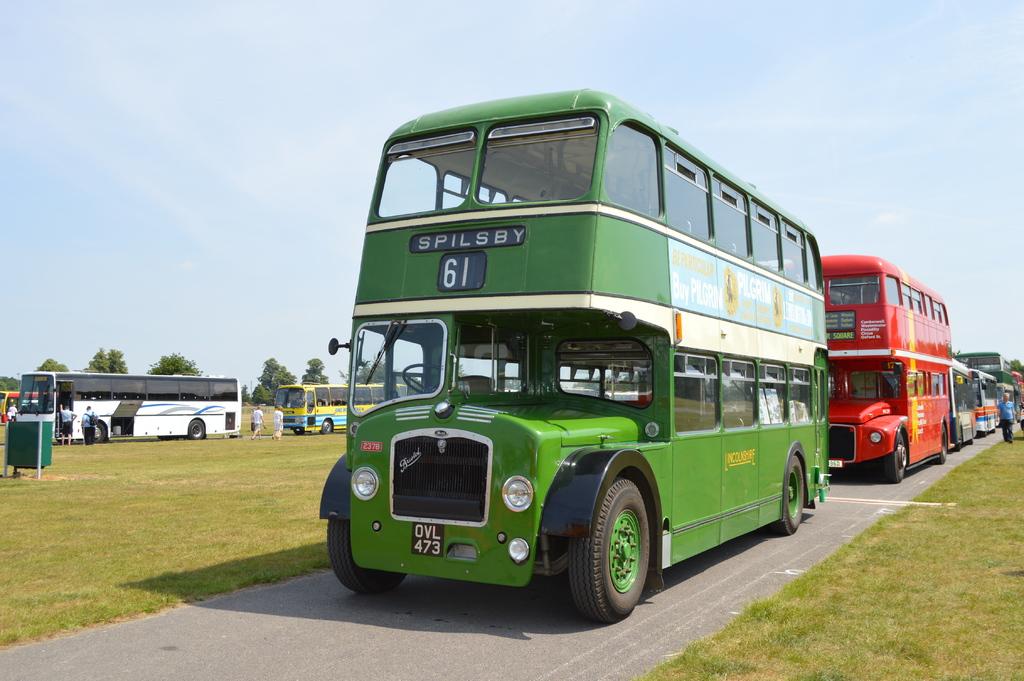Where are the buses going?
Provide a succinct answer. Spilsby. What bus number is that?
Provide a short and direct response. 61. 